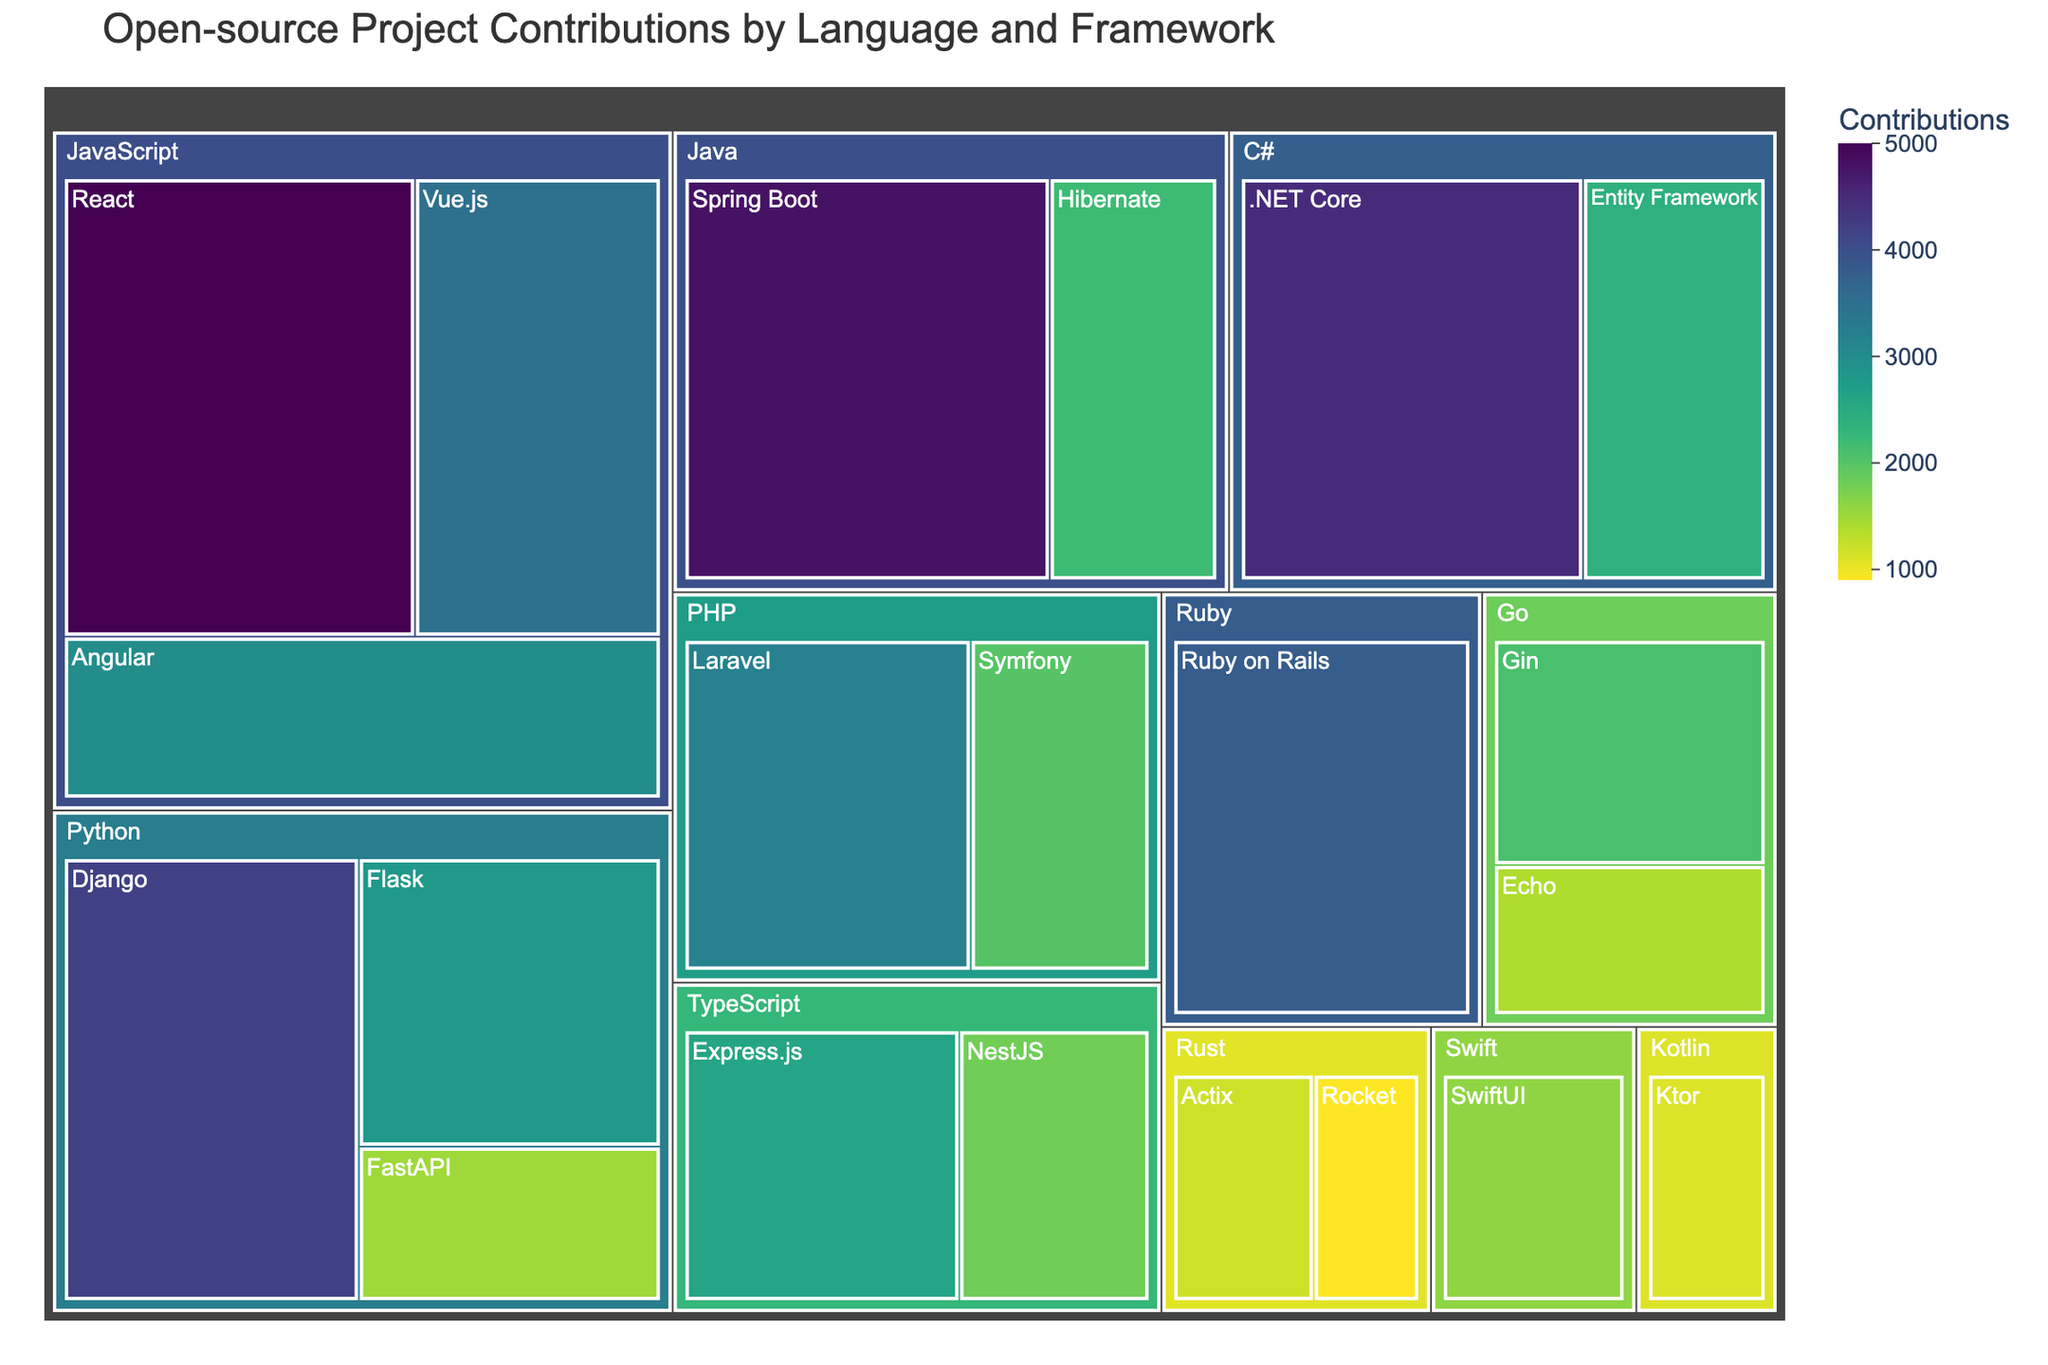Which language has the most contributions overall? By observing the treemap, we can see which language covers the largest area, signifying the highest contributions. JavaScript occupies the largest area, suggesting it has the most contributions.
Answer: JavaScript What is the total number of contributions for Python frameworks? Sum the contributions for Django (4200), Flask (2800), and FastAPI (1500). So, 4200 + 2800 + 1500 = 8500.
Answer: 8500 Between Django and Spring Boot, which has more contributions? Compare the contributions displayed on the figure: Django with 4200 contributions and Spring Boot with 4800 contributions. Spring Boot has more.
Answer: Spring Boot What is the average number of contributions for Java-related frameworks? Add the contributions for Spring Boot (4800) and Hibernate (2200), then divide by 2. (4800 + 2200) / 2 = 7000 / 2 = 3500.
Answer: 3500 Which framework has the least number of contributions in the entire figure? By identifying the framework with the smallest section, it's evident that Rocket has the least with 900 contributions.
Answer: Rocket Is the total number of contributions for PHP frameworks higher or lower than those for C# frameworks? Sum the contributions for PHP (Laravel 3200 + Symfony 2000 = 5200) and for C# (.NET Core 4500 + Entity Framework 2400 = 6900). Compare the totals, 5200 < 6900.
Answer: Lower How many unique languages are represented in the treemap? Each unique color represents a different language. Count the distinct languages present. We have JavaScript, Python, Java, Ruby, PHP, C#, TypeScript, Go, Rust, Swift, and Kotlin, which sums up to 11.
Answer: 11 What is the total contributions for JavaScript frameworks? Sum the contributions for React (5000), Vue.js (3500), and Angular (3000). So, 5000 + 3500 + 3000 = 11500.
Answer: 11500 Compare the contributions between React and Vue.js combined versus all Python frameworks combined. Which is higher? Sum React (5000) and Vue.js (3500) to get 8500. Then sum Python frameworks (Django 4200 + Flask 2800 + FastAPI 1500 = 8500). They are equal.
Answer: Equal What is the percentage contribution of Flask relative to the total contributions for Python? Flask has 2800 contributions. This is out of the total 8500 for Python. Calculate (2800 / 8500) * 100 = 32.94%.
Answer: 32.94% 